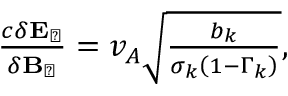Convert formula to latex. <formula><loc_0><loc_0><loc_500><loc_500>\begin{array} { r } { \frac { c \delta E _ { \perp } } { \delta B _ { \perp } } = v _ { A } \sqrt { \frac { b _ { k } } { \sigma _ { k } \left ( 1 - \Gamma _ { k } \right ) } } , } \end{array}</formula> 